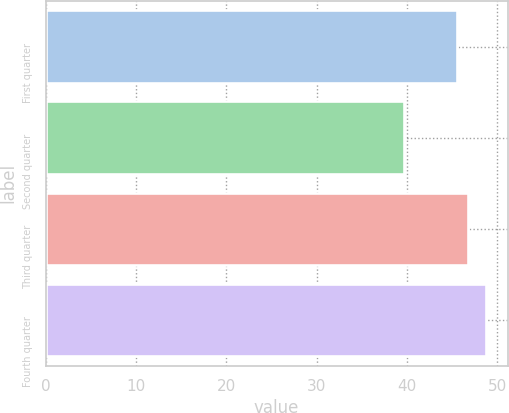<chart> <loc_0><loc_0><loc_500><loc_500><bar_chart><fcel>First quarter<fcel>Second quarter<fcel>Third quarter<fcel>Fourth quarter<nl><fcel>45.57<fcel>39.7<fcel>46.73<fcel>48.72<nl></chart> 